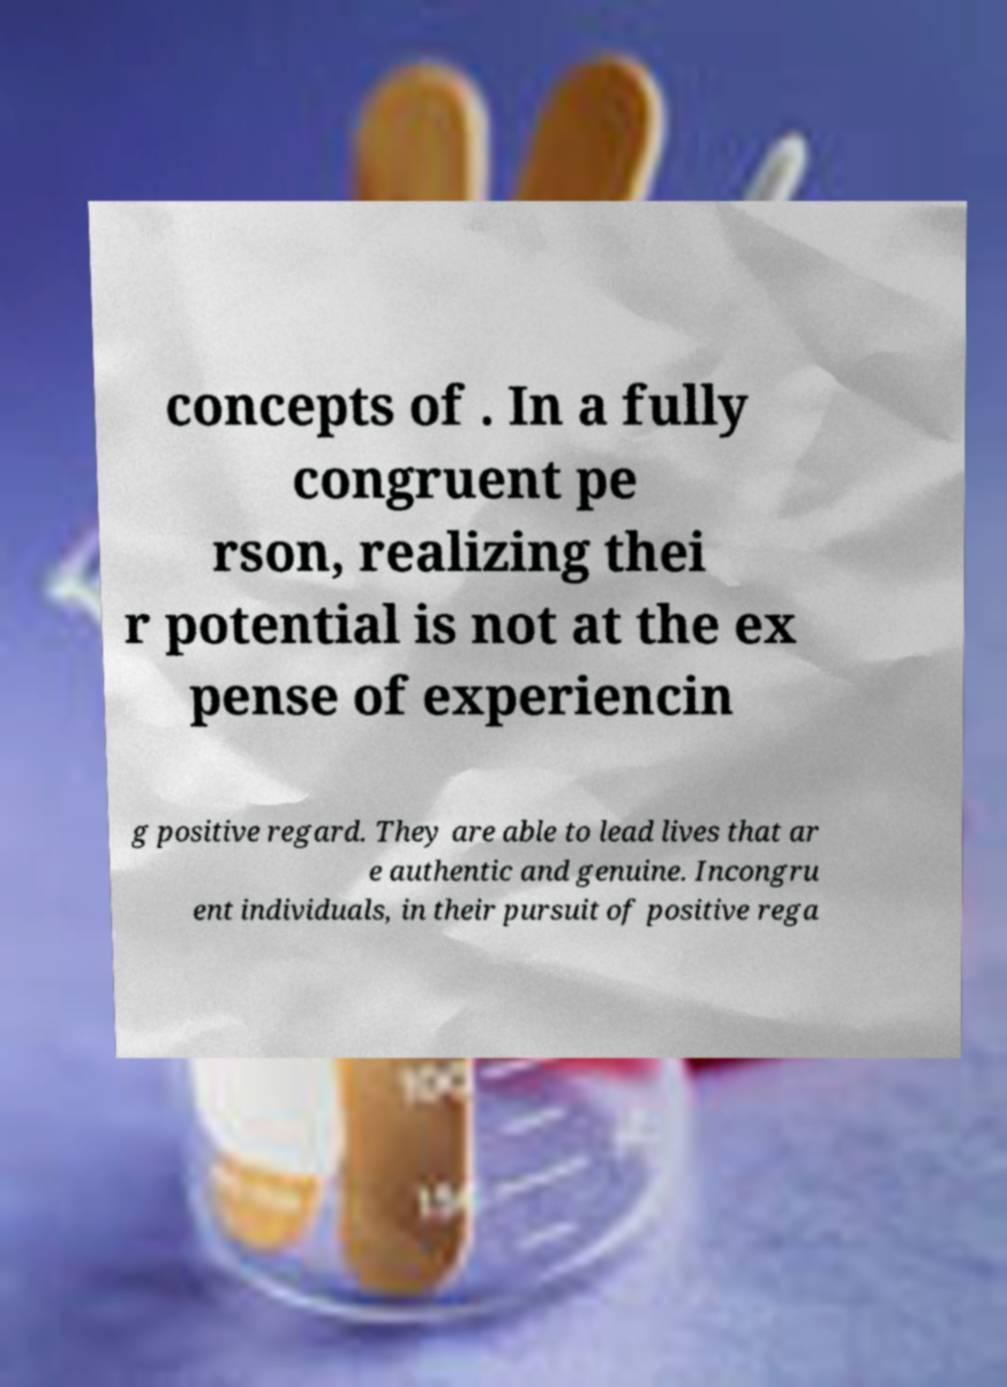I need the written content from this picture converted into text. Can you do that? concepts of . In a fully congruent pe rson, realizing thei r potential is not at the ex pense of experiencin g positive regard. They are able to lead lives that ar e authentic and genuine. Incongru ent individuals, in their pursuit of positive rega 